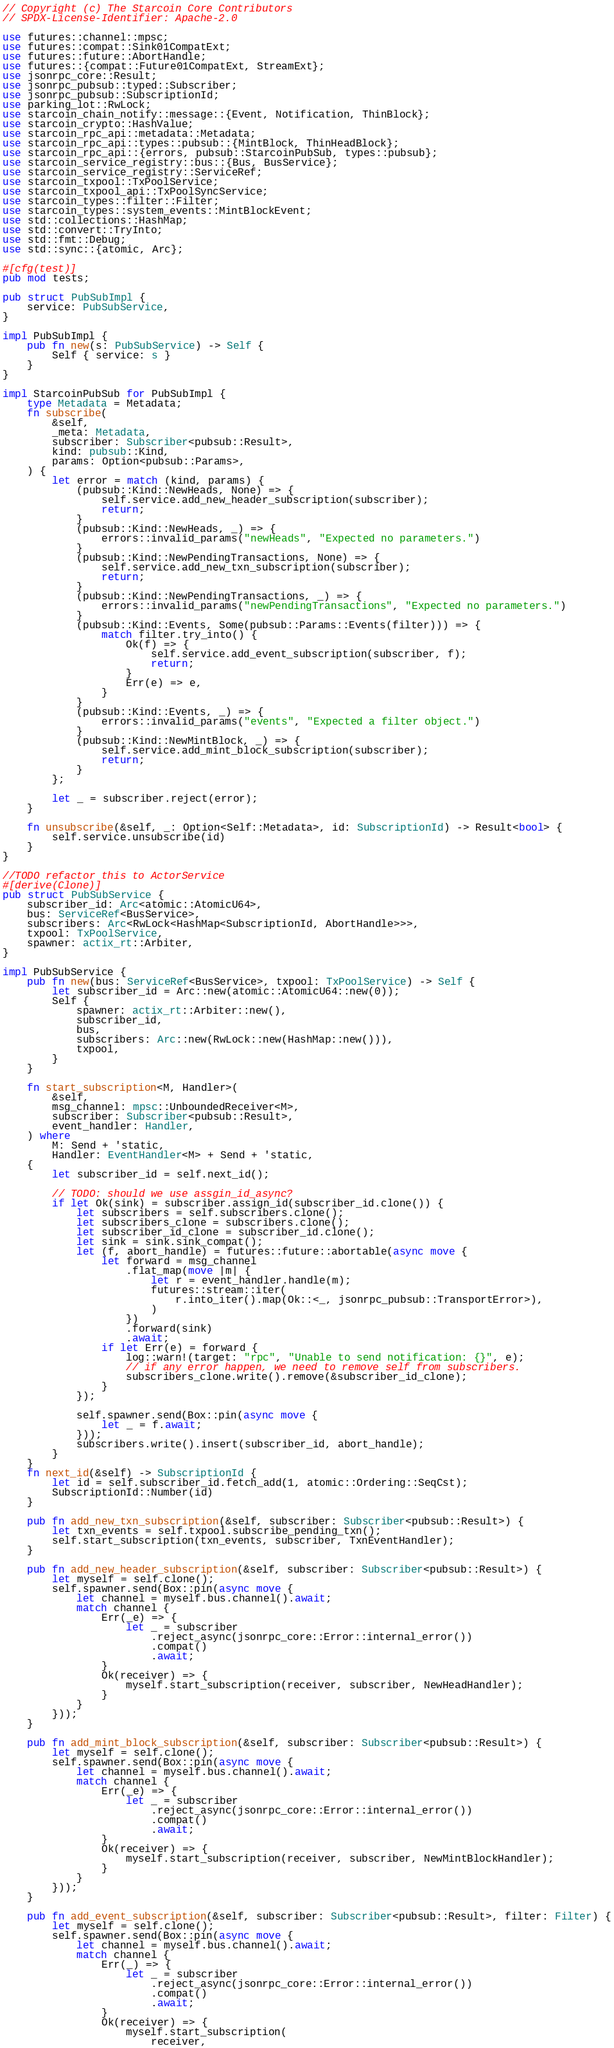Convert code to text. <code><loc_0><loc_0><loc_500><loc_500><_Rust_>// Copyright (c) The Starcoin Core Contributors
// SPDX-License-Identifier: Apache-2.0

use futures::channel::mpsc;
use futures::compat::Sink01CompatExt;
use futures::future::AbortHandle;
use futures::{compat::Future01CompatExt, StreamExt};
use jsonrpc_core::Result;
use jsonrpc_pubsub::typed::Subscriber;
use jsonrpc_pubsub::SubscriptionId;
use parking_lot::RwLock;
use starcoin_chain_notify::message::{Event, Notification, ThinBlock};
use starcoin_crypto::HashValue;
use starcoin_rpc_api::metadata::Metadata;
use starcoin_rpc_api::types::pubsub::{MintBlock, ThinHeadBlock};
use starcoin_rpc_api::{errors, pubsub::StarcoinPubSub, types::pubsub};
use starcoin_service_registry::bus::{Bus, BusService};
use starcoin_service_registry::ServiceRef;
use starcoin_txpool::TxPoolService;
use starcoin_txpool_api::TxPoolSyncService;
use starcoin_types::filter::Filter;
use starcoin_types::system_events::MintBlockEvent;
use std::collections::HashMap;
use std::convert::TryInto;
use std::fmt::Debug;
use std::sync::{atomic, Arc};

#[cfg(test)]
pub mod tests;

pub struct PubSubImpl {
    service: PubSubService,
}

impl PubSubImpl {
    pub fn new(s: PubSubService) -> Self {
        Self { service: s }
    }
}

impl StarcoinPubSub for PubSubImpl {
    type Metadata = Metadata;
    fn subscribe(
        &self,
        _meta: Metadata,
        subscriber: Subscriber<pubsub::Result>,
        kind: pubsub::Kind,
        params: Option<pubsub::Params>,
    ) {
        let error = match (kind, params) {
            (pubsub::Kind::NewHeads, None) => {
                self.service.add_new_header_subscription(subscriber);
                return;
            }
            (pubsub::Kind::NewHeads, _) => {
                errors::invalid_params("newHeads", "Expected no parameters.")
            }
            (pubsub::Kind::NewPendingTransactions, None) => {
                self.service.add_new_txn_subscription(subscriber);
                return;
            }
            (pubsub::Kind::NewPendingTransactions, _) => {
                errors::invalid_params("newPendingTransactions", "Expected no parameters.")
            }
            (pubsub::Kind::Events, Some(pubsub::Params::Events(filter))) => {
                match filter.try_into() {
                    Ok(f) => {
                        self.service.add_event_subscription(subscriber, f);
                        return;
                    }
                    Err(e) => e,
                }
            }
            (pubsub::Kind::Events, _) => {
                errors::invalid_params("events", "Expected a filter object.")
            }
            (pubsub::Kind::NewMintBlock, _) => {
                self.service.add_mint_block_subscription(subscriber);
                return;
            }
        };

        let _ = subscriber.reject(error);
    }

    fn unsubscribe(&self, _: Option<Self::Metadata>, id: SubscriptionId) -> Result<bool> {
        self.service.unsubscribe(id)
    }
}

//TODO refactor this to ActorService
#[derive(Clone)]
pub struct PubSubService {
    subscriber_id: Arc<atomic::AtomicU64>,
    bus: ServiceRef<BusService>,
    subscribers: Arc<RwLock<HashMap<SubscriptionId, AbortHandle>>>,
    txpool: TxPoolService,
    spawner: actix_rt::Arbiter,
}

impl PubSubService {
    pub fn new(bus: ServiceRef<BusService>, txpool: TxPoolService) -> Self {
        let subscriber_id = Arc::new(atomic::AtomicU64::new(0));
        Self {
            spawner: actix_rt::Arbiter::new(),
            subscriber_id,
            bus,
            subscribers: Arc::new(RwLock::new(HashMap::new())),
            txpool,
        }
    }

    fn start_subscription<M, Handler>(
        &self,
        msg_channel: mpsc::UnboundedReceiver<M>,
        subscriber: Subscriber<pubsub::Result>,
        event_handler: Handler,
    ) where
        M: Send + 'static,
        Handler: EventHandler<M> + Send + 'static,
    {
        let subscriber_id = self.next_id();

        // TODO: should we use assgin_id_async?
        if let Ok(sink) = subscriber.assign_id(subscriber_id.clone()) {
            let subscribers = self.subscribers.clone();
            let subscribers_clone = subscribers.clone();
            let subscriber_id_clone = subscriber_id.clone();
            let sink = sink.sink_compat();
            let (f, abort_handle) = futures::future::abortable(async move {
                let forward = msg_channel
                    .flat_map(move |m| {
                        let r = event_handler.handle(m);
                        futures::stream::iter(
                            r.into_iter().map(Ok::<_, jsonrpc_pubsub::TransportError>),
                        )
                    })
                    .forward(sink)
                    .await;
                if let Err(e) = forward {
                    log::warn!(target: "rpc", "Unable to send notification: {}", e);
                    // if any error happen, we need to remove self from subscribers.
                    subscribers_clone.write().remove(&subscriber_id_clone);
                }
            });

            self.spawner.send(Box::pin(async move {
                let _ = f.await;
            }));
            subscribers.write().insert(subscriber_id, abort_handle);
        }
    }
    fn next_id(&self) -> SubscriptionId {
        let id = self.subscriber_id.fetch_add(1, atomic::Ordering::SeqCst);
        SubscriptionId::Number(id)
    }

    pub fn add_new_txn_subscription(&self, subscriber: Subscriber<pubsub::Result>) {
        let txn_events = self.txpool.subscribe_pending_txn();
        self.start_subscription(txn_events, subscriber, TxnEventHandler);
    }

    pub fn add_new_header_subscription(&self, subscriber: Subscriber<pubsub::Result>) {
        let myself = self.clone();
        self.spawner.send(Box::pin(async move {
            let channel = myself.bus.channel().await;
            match channel {
                Err(_e) => {
                    let _ = subscriber
                        .reject_async(jsonrpc_core::Error::internal_error())
                        .compat()
                        .await;
                }
                Ok(receiver) => {
                    myself.start_subscription(receiver, subscriber, NewHeadHandler);
                }
            }
        }));
    }

    pub fn add_mint_block_subscription(&self, subscriber: Subscriber<pubsub::Result>) {
        let myself = self.clone();
        self.spawner.send(Box::pin(async move {
            let channel = myself.bus.channel().await;
            match channel {
                Err(_e) => {
                    let _ = subscriber
                        .reject_async(jsonrpc_core::Error::internal_error())
                        .compat()
                        .await;
                }
                Ok(receiver) => {
                    myself.start_subscription(receiver, subscriber, NewMintBlockHandler);
                }
            }
        }));
    }

    pub fn add_event_subscription(&self, subscriber: Subscriber<pubsub::Result>, filter: Filter) {
        let myself = self.clone();
        self.spawner.send(Box::pin(async move {
            let channel = myself.bus.channel().await;
            match channel {
                Err(_) => {
                    let _ = subscriber
                        .reject_async(jsonrpc_core::Error::internal_error())
                        .compat()
                        .await;
                }
                Ok(receiver) => {
                    myself.start_subscription(
                        receiver,</code> 